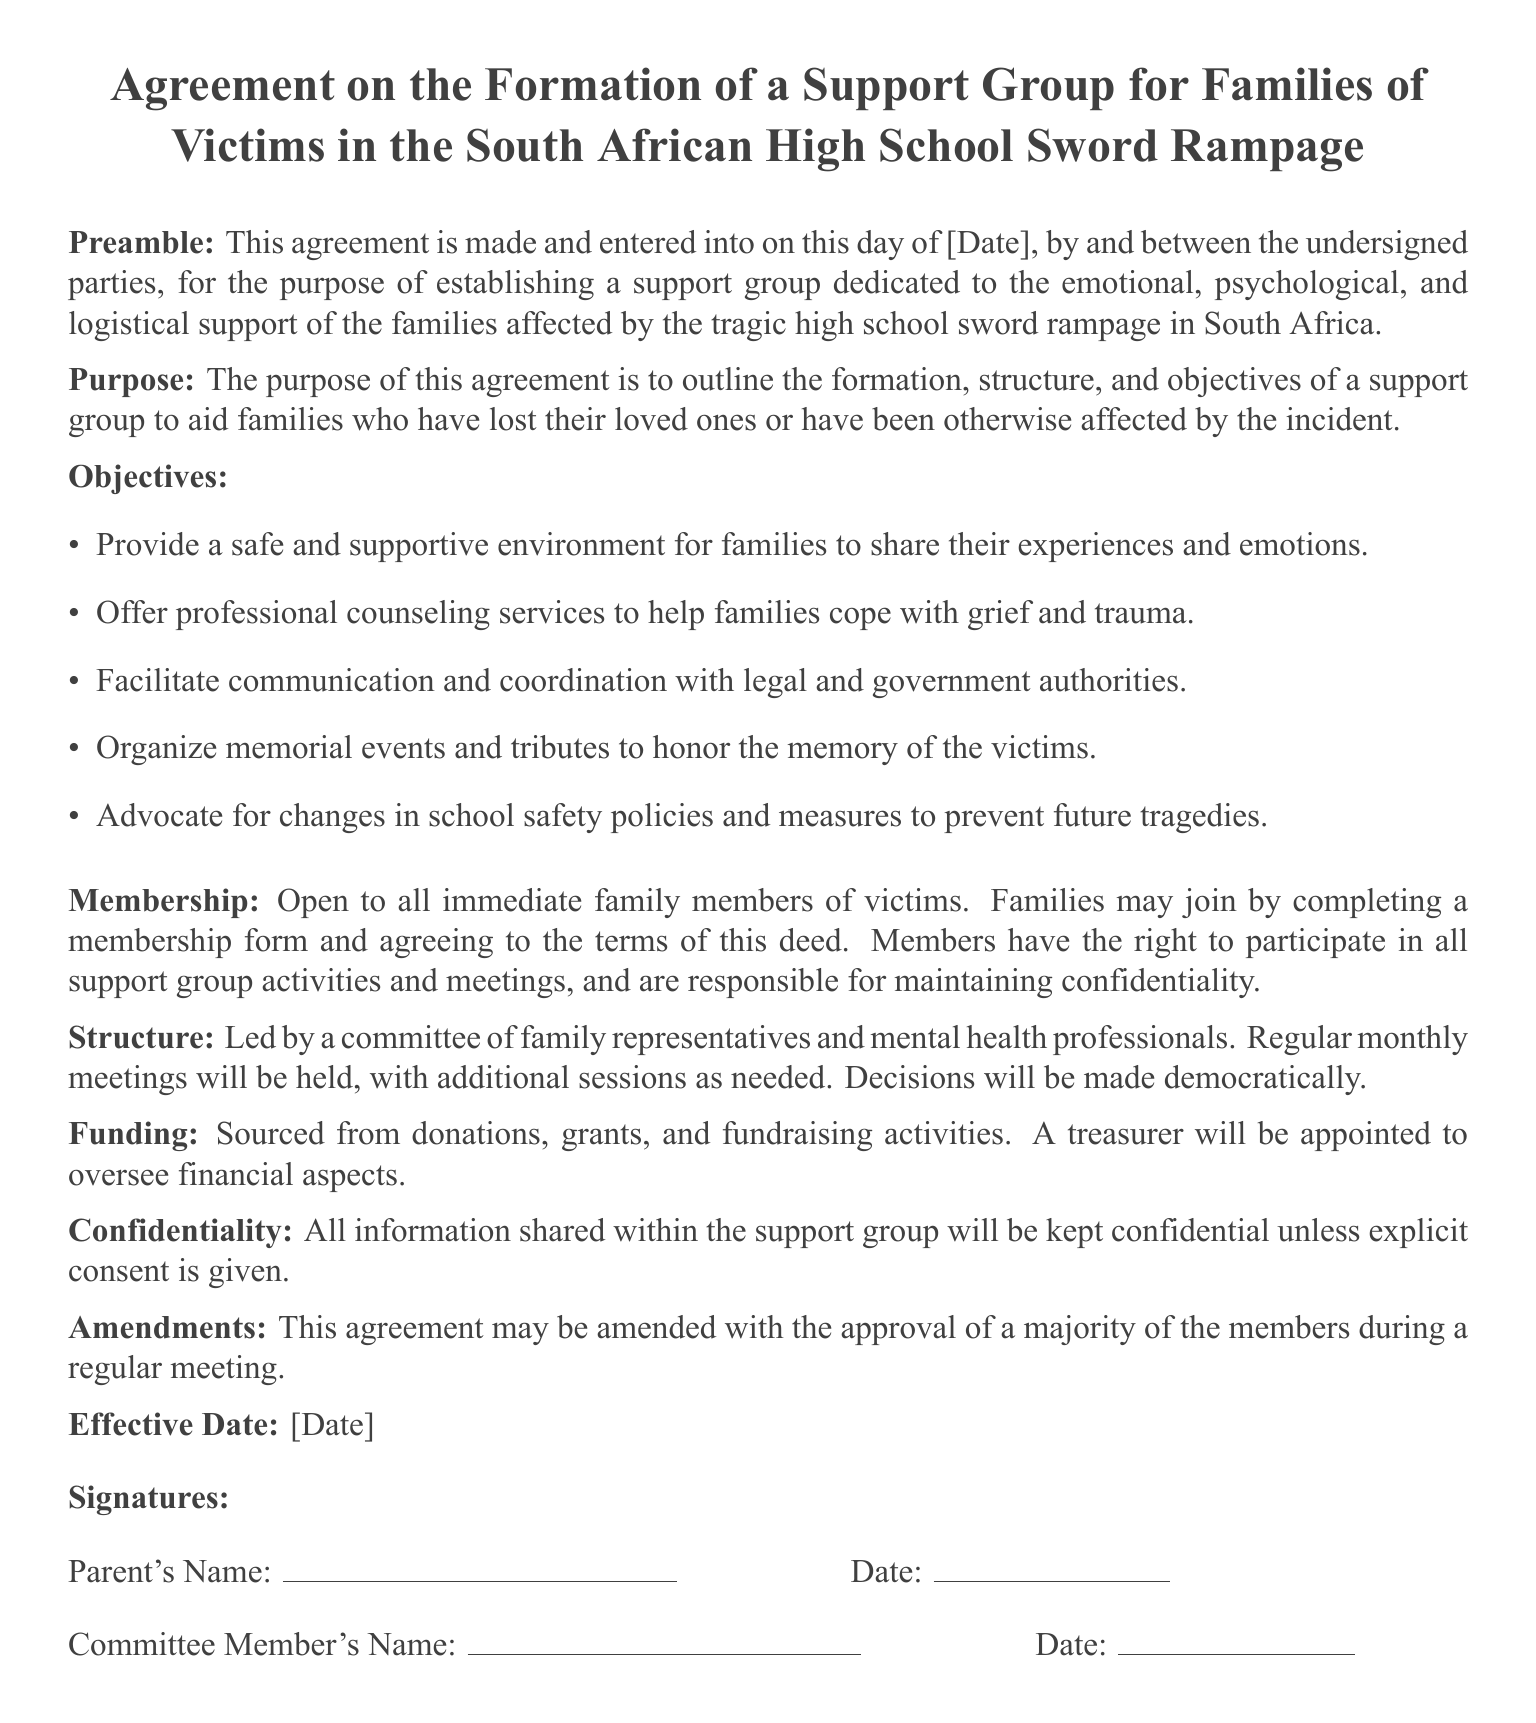What is the title of the document? The title is specified in the beginning of the document as the purpose of the agreement.
Answer: Agreement on the Formation of a Support Group for Families of Victims in the South African High School Sword Rampage What is the main purpose of this agreement? The purpose is clearly stated at the beginning of the document to outline the support group's establishment for victim families.
Answer: To outline the formation, structure, and objectives of a support group Who can become a member of the support group? Membership criteria are specified in the document under 'Membership'.
Answer: Immediate family members of victims How often will the support group meet? The frequency of meetings is mentioned in the 'Structure' section of the document.
Answer: Regular monthly meetings What type of funding will the support group receive? The document mentions various sources of funding under the 'Funding' section.
Answer: Donations, grants, and fundraising activities What is required for information shared in the support group? The document addresses confidentiality in the 'Confidentiality' section.
Answer: Kept confidential unless explicit consent is given What is the role of the treasurer in the support group? The role is specified in the 'Funding' section regarding financial oversight.
Answer: Oversee financial aspects What can be amended according to this agreement? The document describes what can be amended in the 'Amendments' section.
Answer: This agreement When was the agreement made? The date of agreement is indicated as a placeholder in the document.
Answer: [Date] 